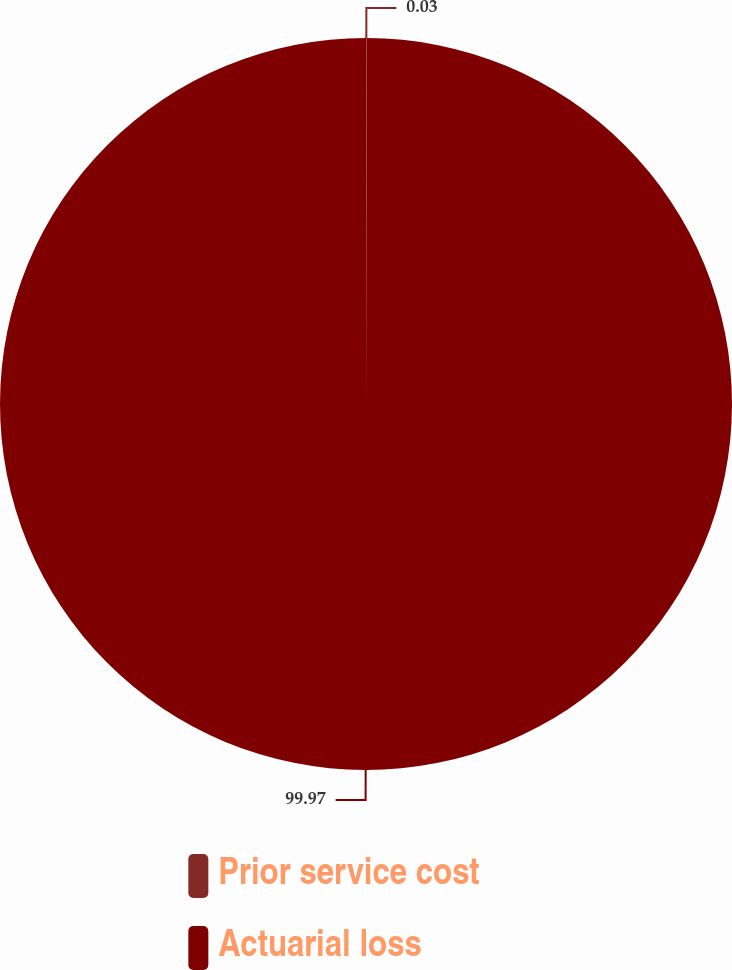<chart> <loc_0><loc_0><loc_500><loc_500><pie_chart><fcel>Prior service cost<fcel>Actuarial loss<nl><fcel>0.03%<fcel>99.97%<nl></chart> 